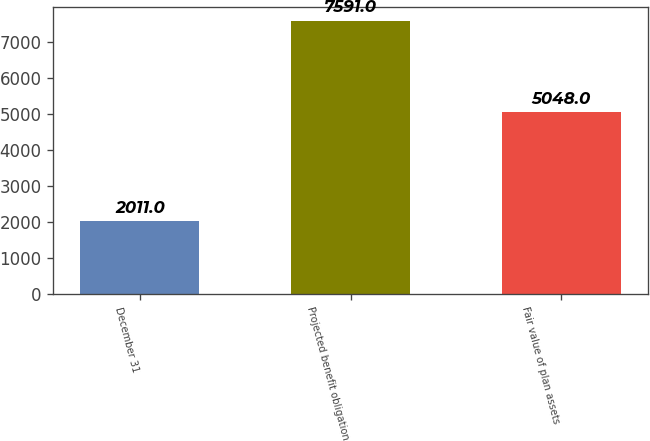Convert chart. <chart><loc_0><loc_0><loc_500><loc_500><bar_chart><fcel>December 31<fcel>Projected benefit obligation<fcel>Fair value of plan assets<nl><fcel>2011<fcel>7591<fcel>5048<nl></chart> 